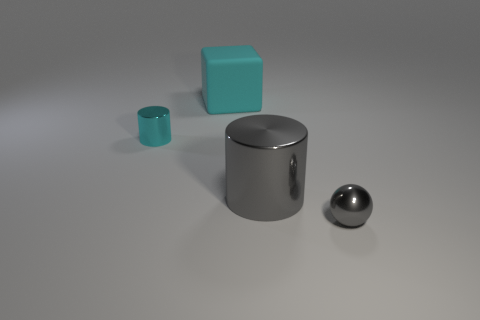Add 4 gray cylinders. How many objects exist? 8 Subtract 1 balls. How many balls are left? 0 Subtract all balls. How many objects are left? 3 Add 1 big cyan objects. How many big cyan objects are left? 2 Add 1 big cyan matte cubes. How many big cyan matte cubes exist? 2 Subtract 0 purple balls. How many objects are left? 4 Subtract all gray cylinders. Subtract all gray blocks. How many cylinders are left? 1 Subtract all green blocks. How many gray cylinders are left? 1 Subtract all large red cubes. Subtract all big cyan rubber cubes. How many objects are left? 3 